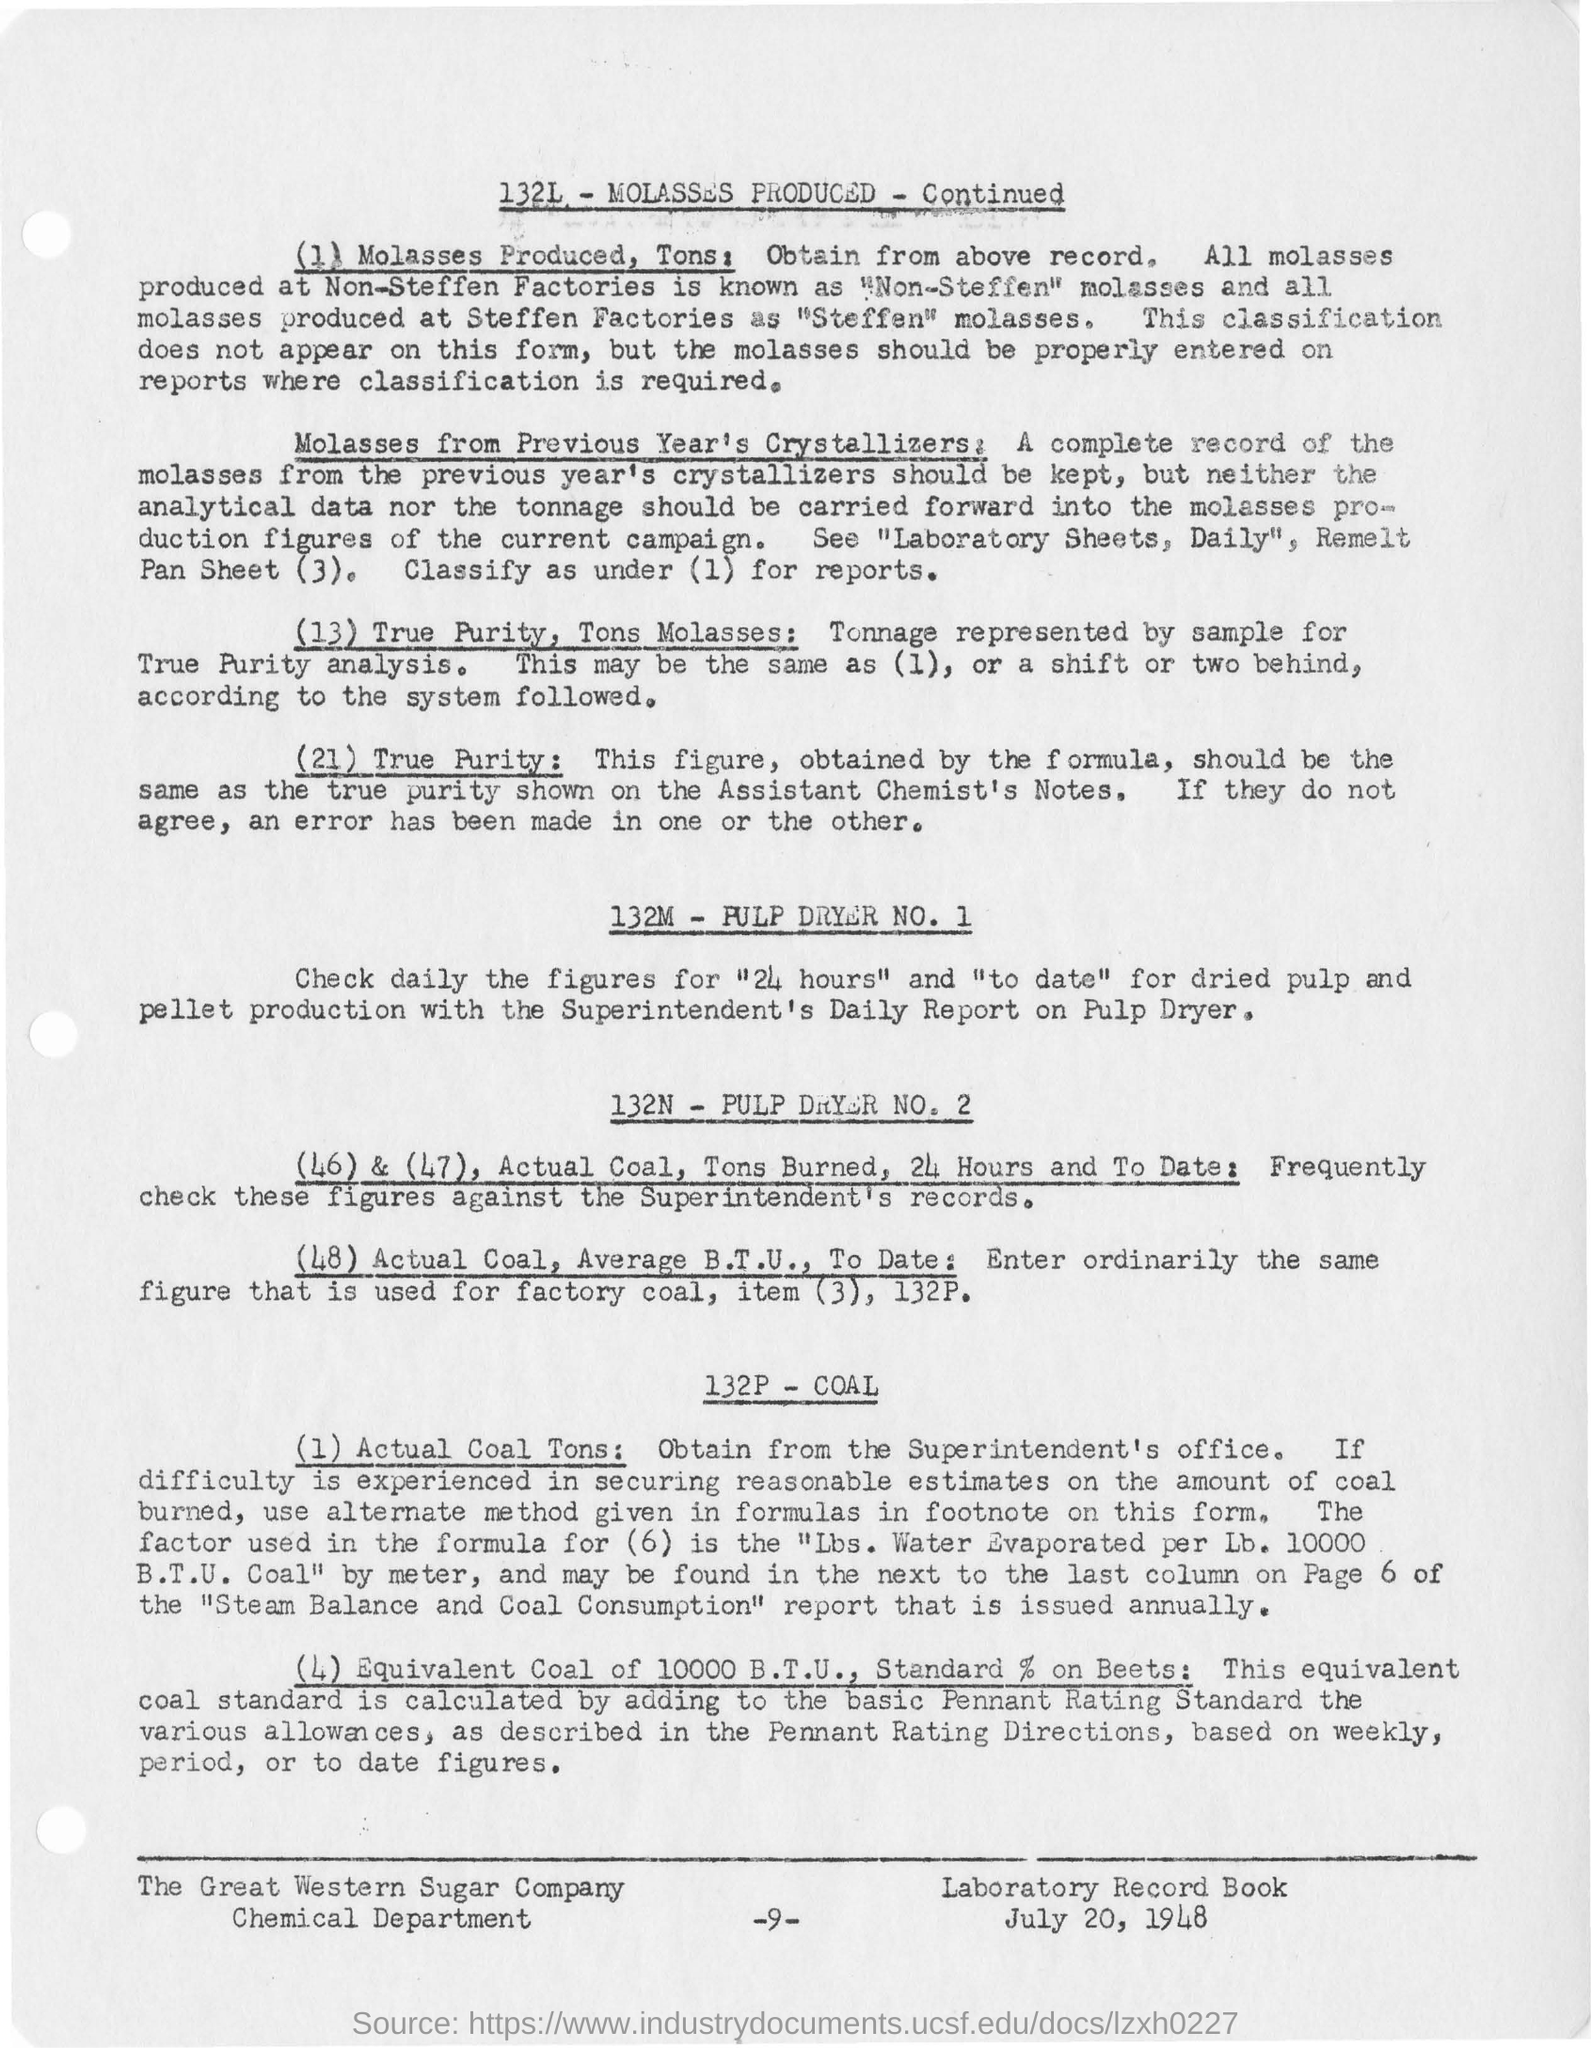Indicate a few pertinent items in this graphic. The document was dated July 20, 1948. The Great Western Sugar Company's chemical department is mentioned. 